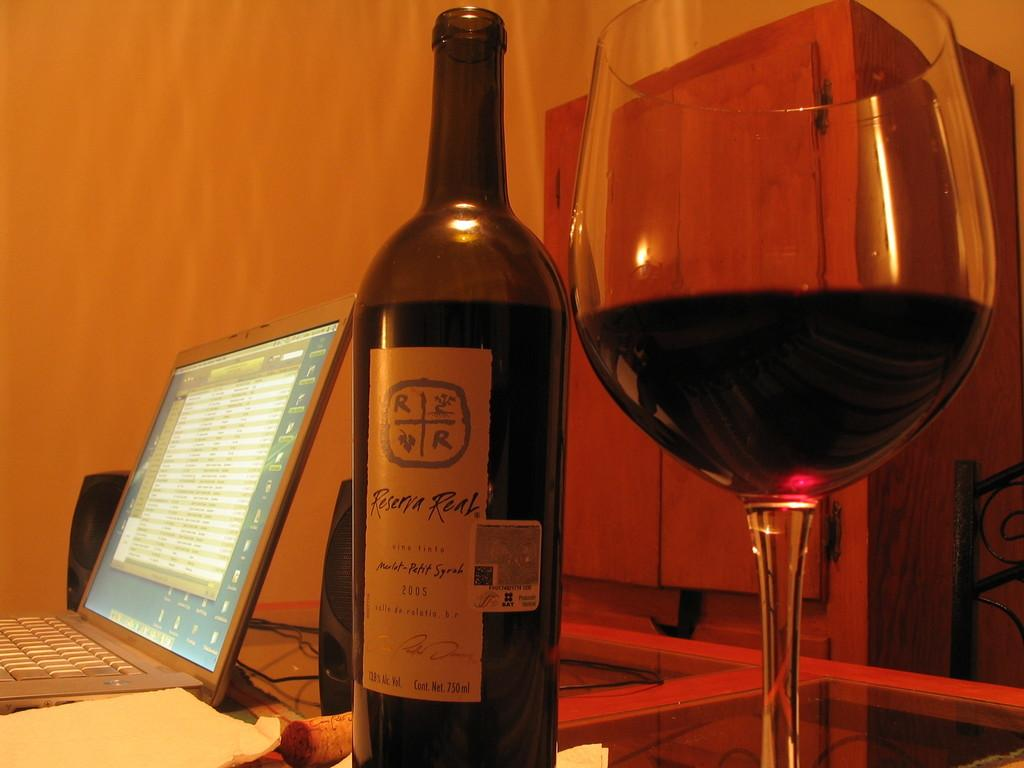<image>
Offer a succinct explanation of the picture presented. Wine bottle with the year 2005 on it next to some cups. 